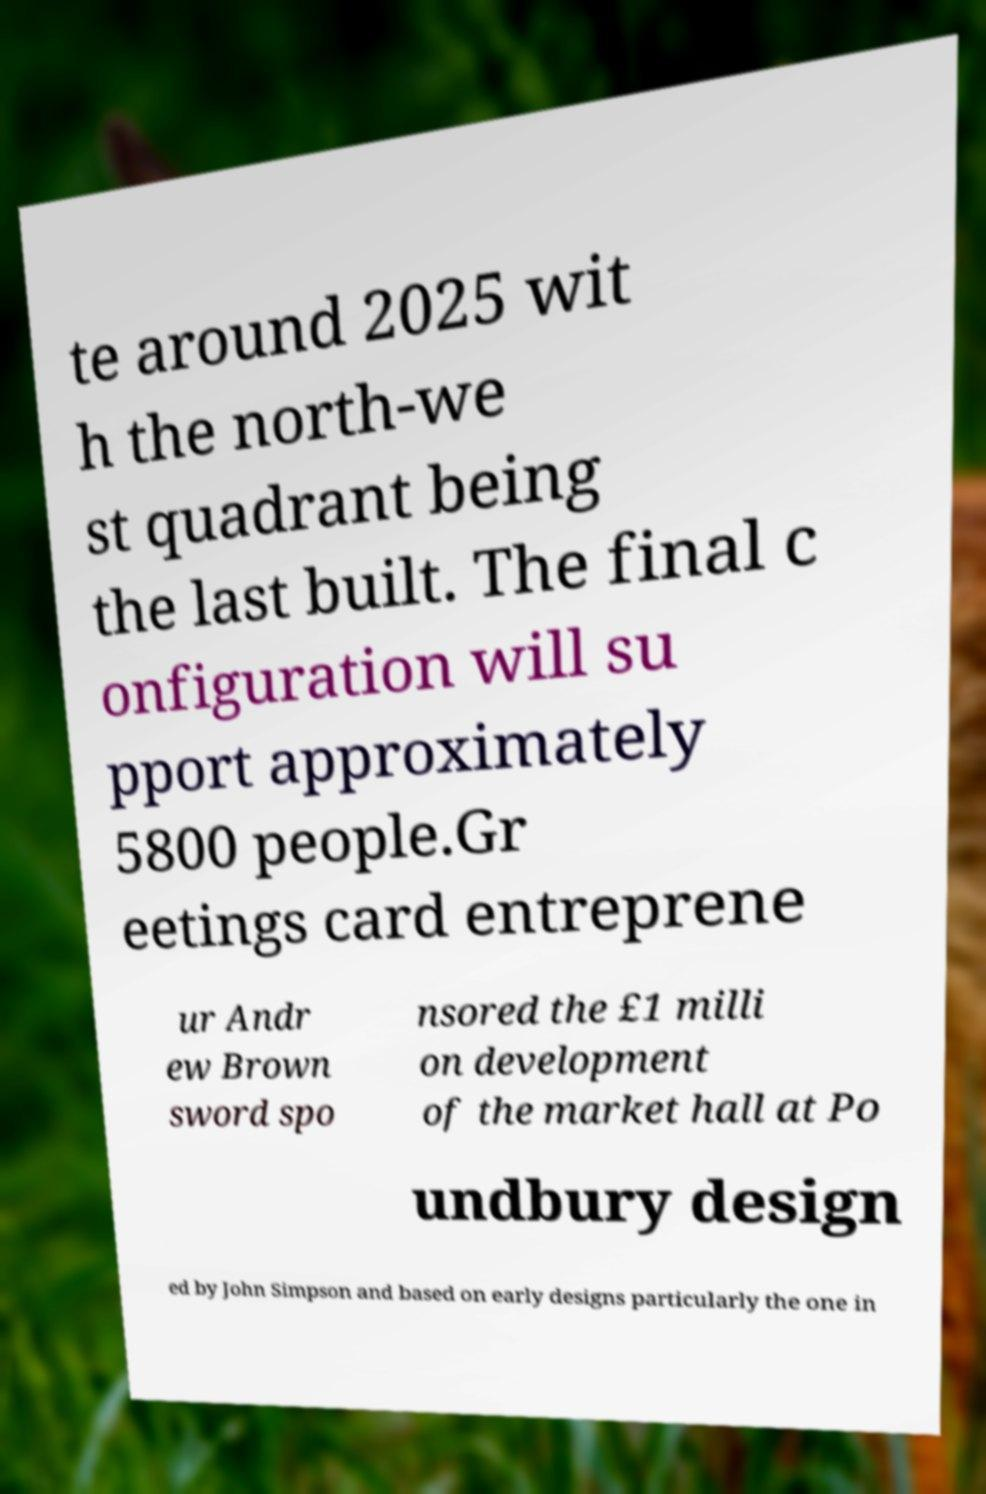Could you assist in decoding the text presented in this image and type it out clearly? te around 2025 wit h the north-we st quadrant being the last built. The final c onfiguration will su pport approximately 5800 people.Gr eetings card entreprene ur Andr ew Brown sword spo nsored the £1 milli on development of the market hall at Po undbury design ed by John Simpson and based on early designs particularly the one in 